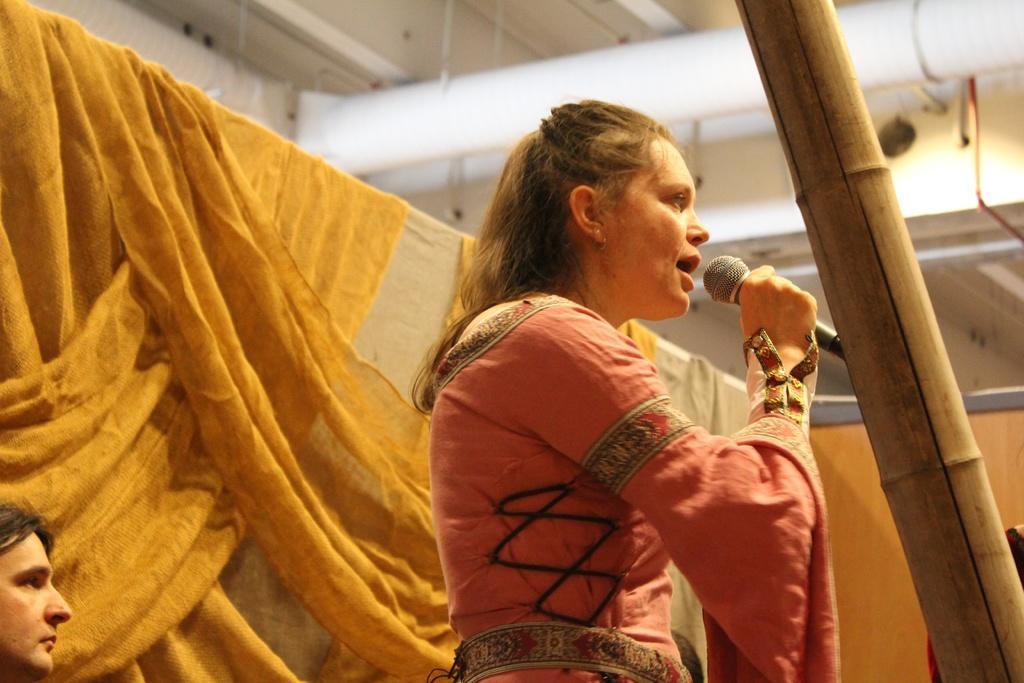In one or two sentences, can you explain what this image depicts? In this image I see a woman, who is standing and she is holding a mic, I can also see that she is wearing a pink dress. In the background I see another person over here and the cloth. I can also see a wooden stick over here. 